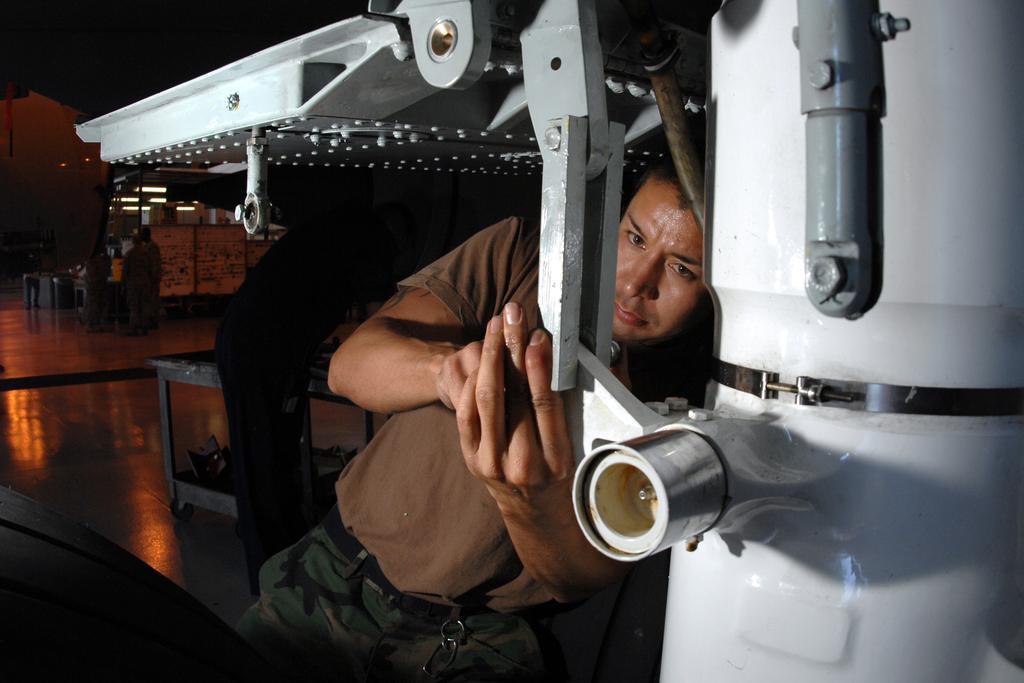Could you give a brief overview of what you see in this image? In this picture we can see people on the floor and we can see metal objects, lights and in the background we can see it is dark. 